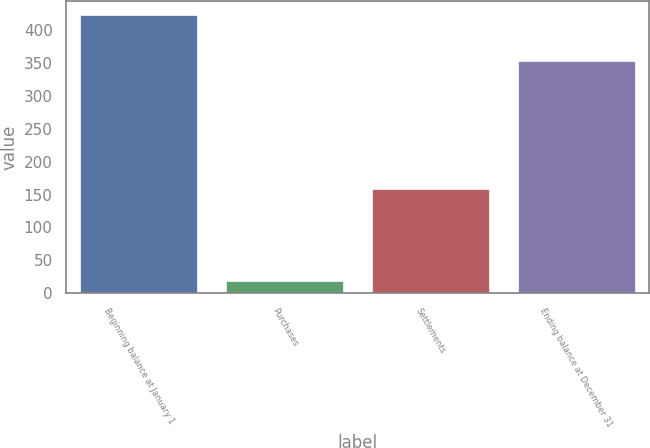Convert chart to OTSL. <chart><loc_0><loc_0><loc_500><loc_500><bar_chart><fcel>Beginning balance at January 1<fcel>Purchases<fcel>Settlements<fcel>Ending balance at December 31<nl><fcel>422<fcel>19<fcel>158<fcel>352<nl></chart> 